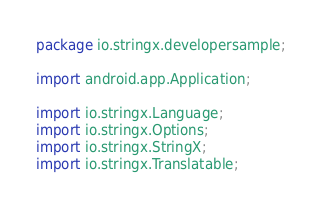Convert code to text. <code><loc_0><loc_0><loc_500><loc_500><_Java_>package io.stringx.developersample;

import android.app.Application;

import io.stringx.Language;
import io.stringx.Options;
import io.stringx.StringX;
import io.stringx.Translatable;
</code> 